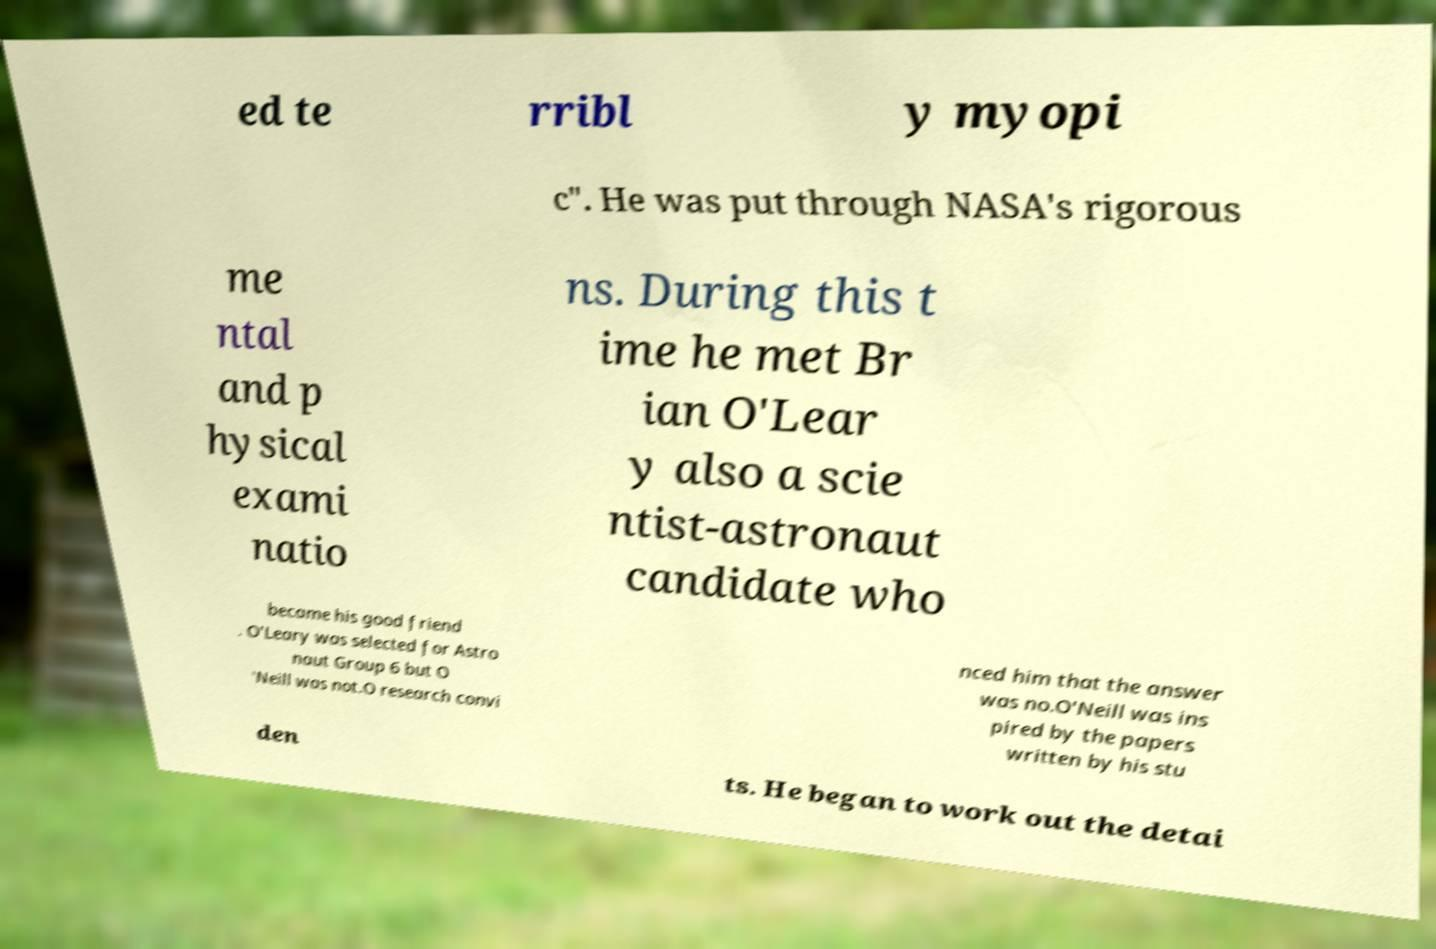For documentation purposes, I need the text within this image transcribed. Could you provide that? ed te rribl y myopi c". He was put through NASA's rigorous me ntal and p hysical exami natio ns. During this t ime he met Br ian O'Lear y also a scie ntist-astronaut candidate who became his good friend . O'Leary was selected for Astro naut Group 6 but O 'Neill was not.O research convi nced him that the answer was no.O'Neill was ins pired by the papers written by his stu den ts. He began to work out the detai 